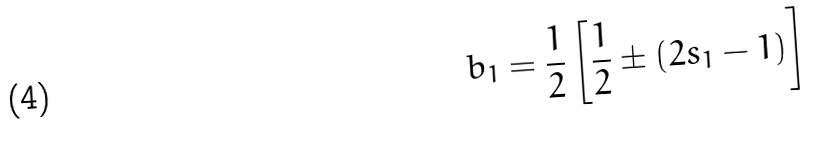<formula> <loc_0><loc_0><loc_500><loc_500>b _ { 1 } = \frac { 1 } { 2 } \left [ \frac { 1 } { 2 } \pm ( 2 s _ { 1 } - 1 ) \right ]</formula> 